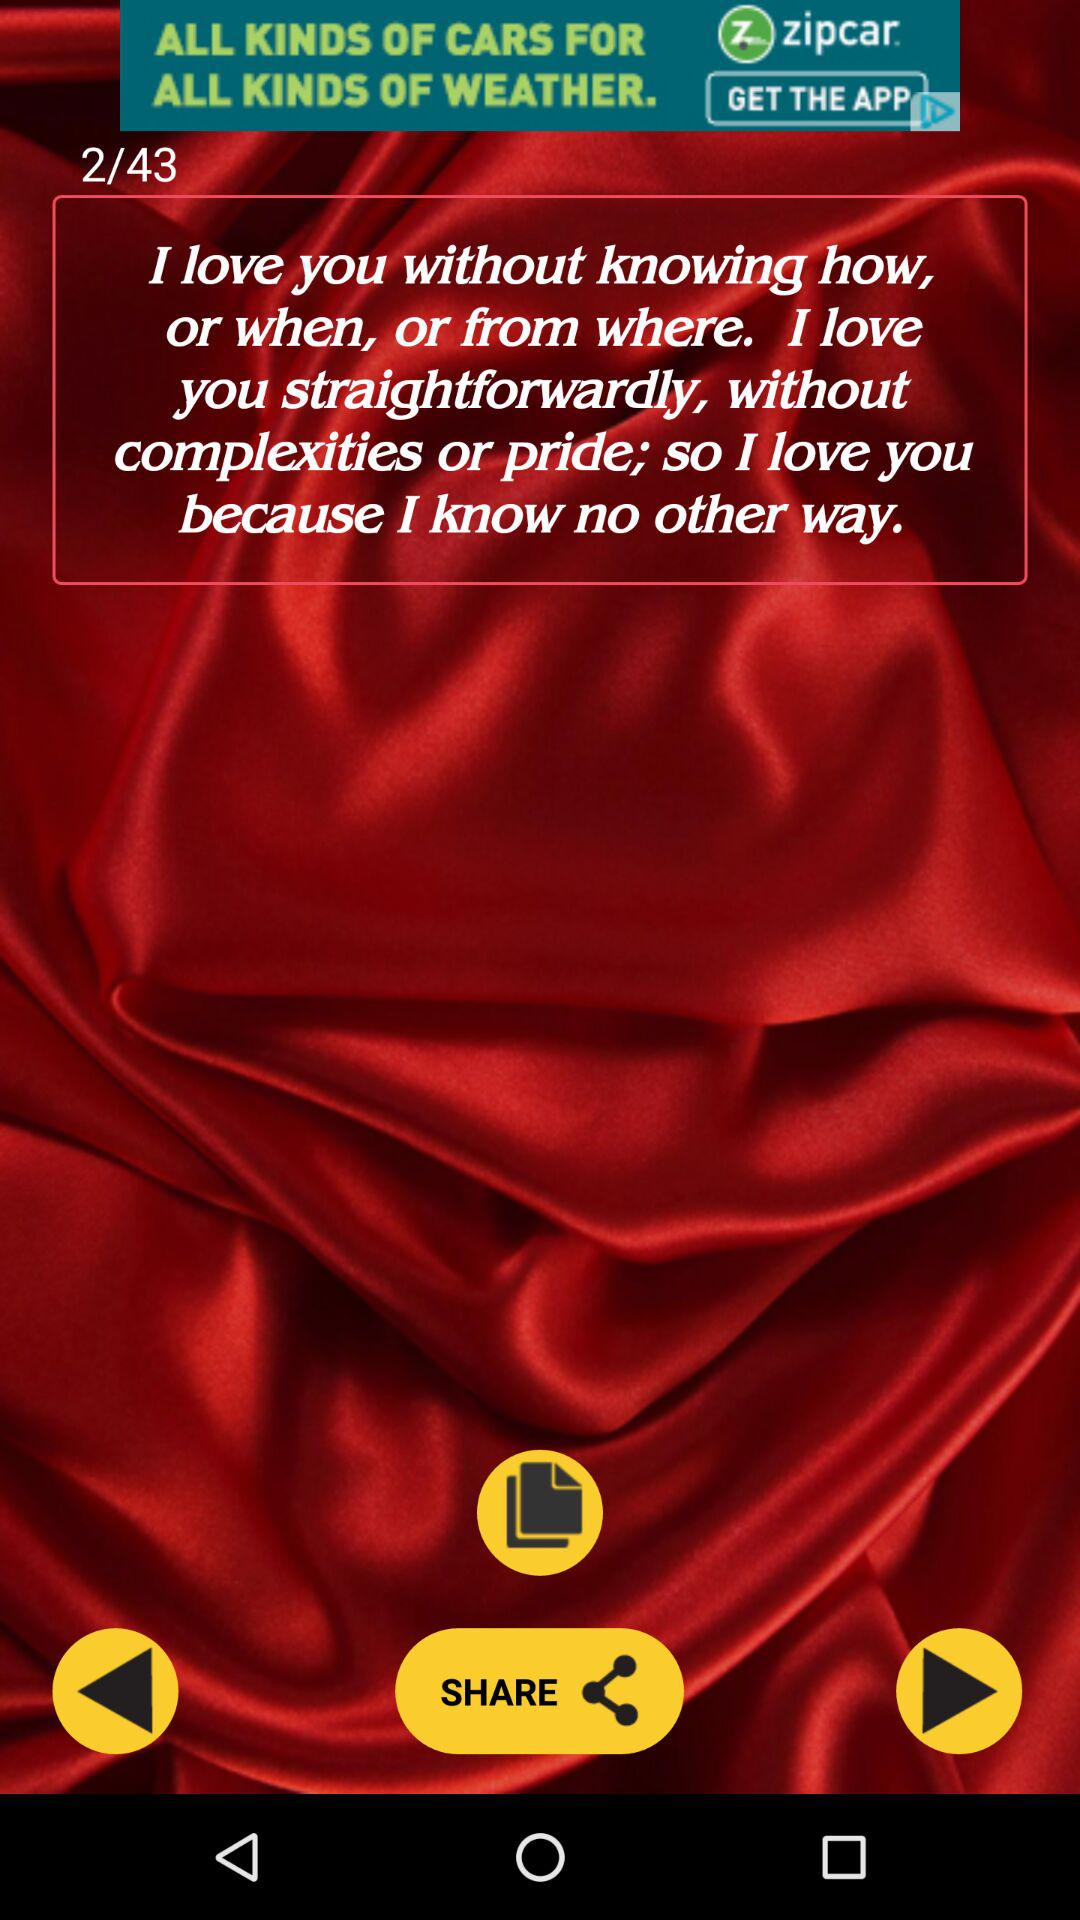What is the image number a person is currently at? A person is currently at image number 2. 